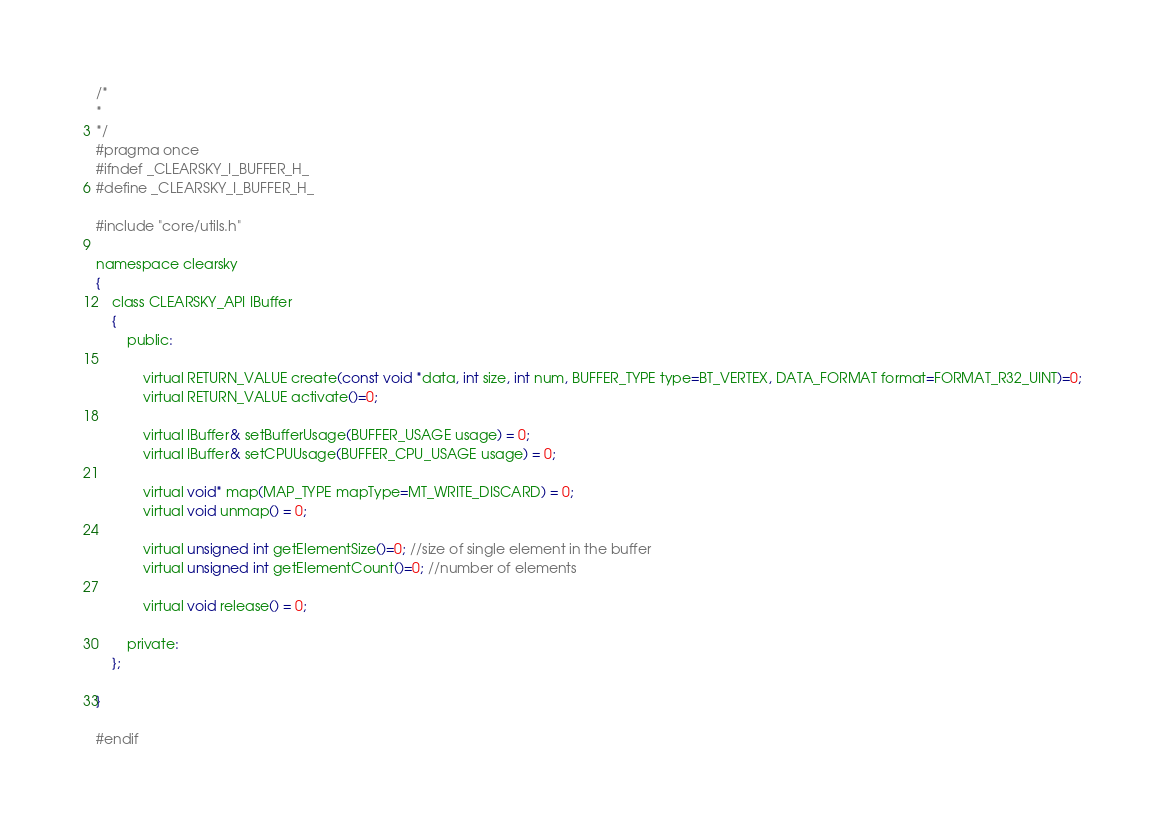Convert code to text. <code><loc_0><loc_0><loc_500><loc_500><_C_>/*
*
*/
#pragma once
#ifndef _CLEARSKY_I_BUFFER_H_
#define _CLEARSKY_I_BUFFER_H_

#include "core/utils.h"

namespace clearsky
{
	class CLEARSKY_API IBuffer
	{
		public:

			virtual RETURN_VALUE create(const void *data, int size, int num, BUFFER_TYPE type=BT_VERTEX, DATA_FORMAT format=FORMAT_R32_UINT)=0;
			virtual RETURN_VALUE activate()=0;

			virtual IBuffer& setBufferUsage(BUFFER_USAGE usage) = 0;
			virtual IBuffer& setCPUUsage(BUFFER_CPU_USAGE usage) = 0;

			virtual void* map(MAP_TYPE mapType=MT_WRITE_DISCARD) = 0;
			virtual void unmap() = 0;

			virtual unsigned int getElementSize()=0; //size of single element in the buffer
			virtual unsigned int getElementCount()=0; //number of elements

			virtual void release() = 0;

		private:
	};

}

#endif</code> 